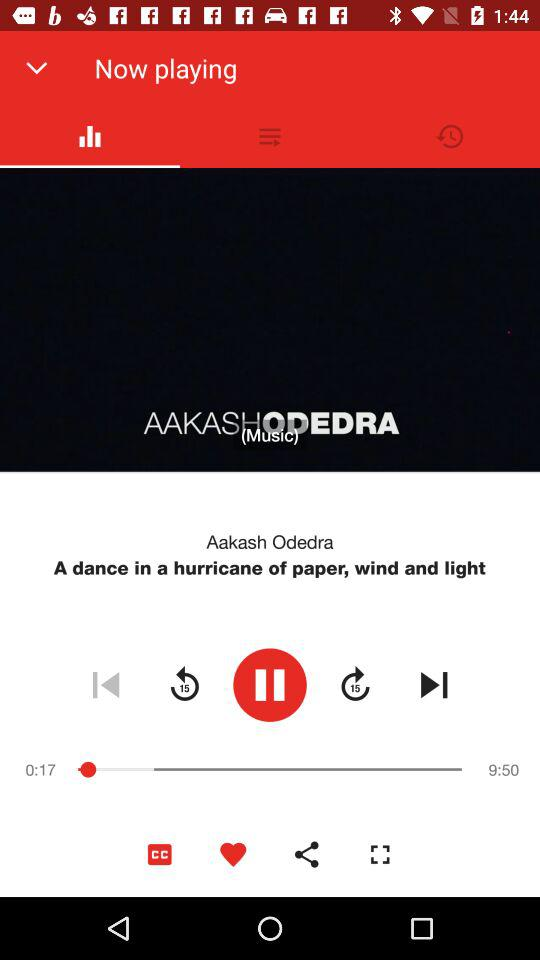Which song is currently playing? The currently playing song is "A dance in a hurricane of paper, wind and light". 